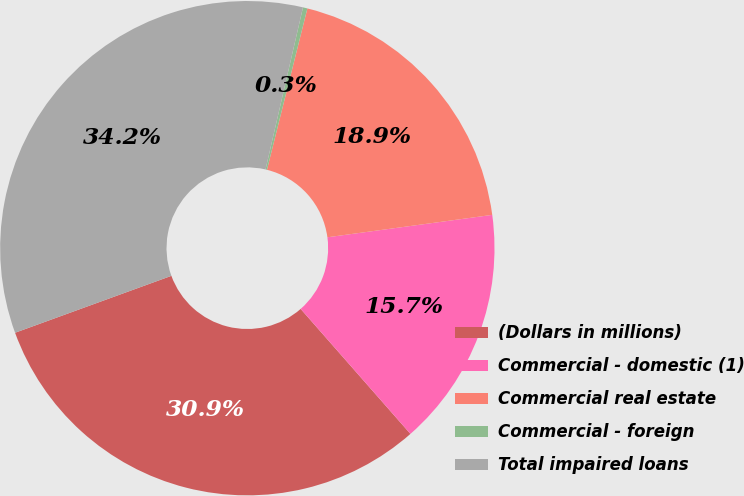Convert chart to OTSL. <chart><loc_0><loc_0><loc_500><loc_500><pie_chart><fcel>(Dollars in millions)<fcel>Commercial - domestic (1)<fcel>Commercial real estate<fcel>Commercial - foreign<fcel>Total impaired loans<nl><fcel>30.91%<fcel>15.68%<fcel>18.94%<fcel>0.29%<fcel>34.17%<nl></chart> 